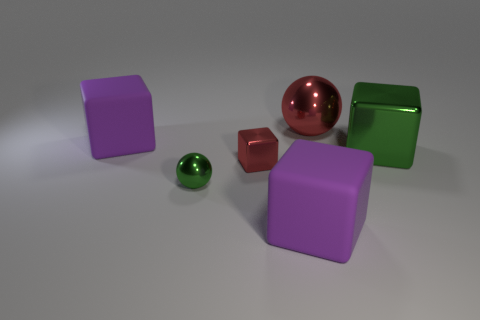Subtract 1 blocks. How many blocks are left? 3 Add 1 big purple cubes. How many objects exist? 7 Subtract all balls. How many objects are left? 4 Add 5 purple rubber objects. How many purple rubber objects are left? 7 Add 5 blocks. How many blocks exist? 9 Subtract 2 purple blocks. How many objects are left? 4 Subtract all tiny green metal balls. Subtract all purple matte cylinders. How many objects are left? 5 